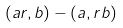<formula> <loc_0><loc_0><loc_500><loc_500>( a r , b ) - ( a , r b )</formula> 